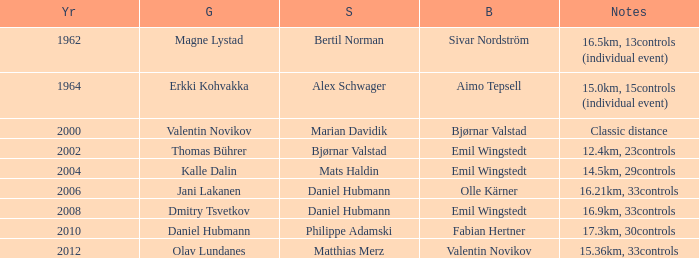What does the 1962 silver refer to? Bertil Norman. 